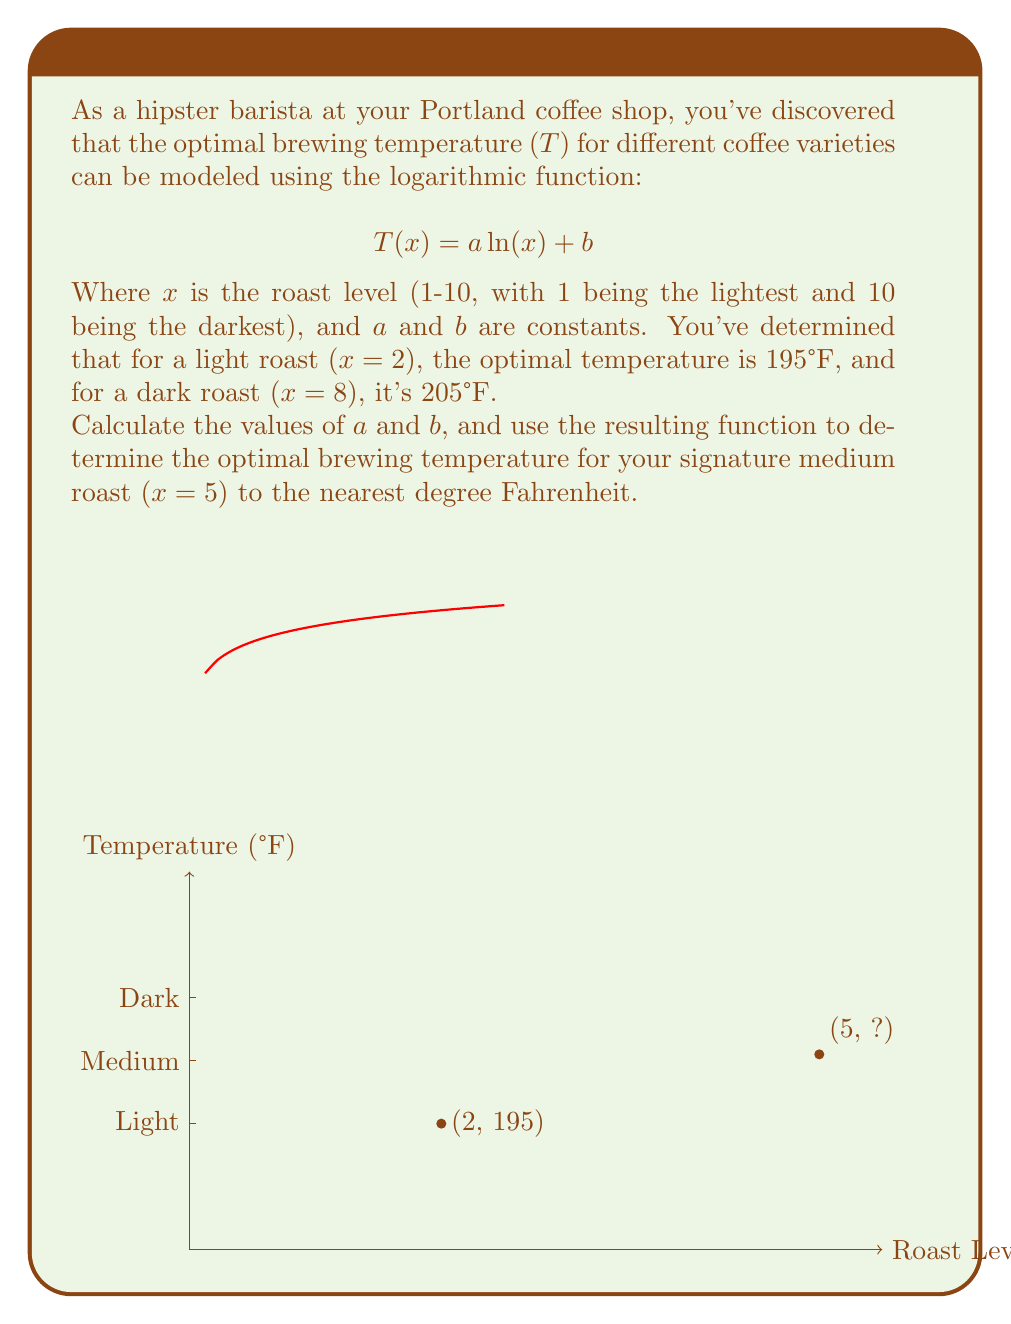Show me your answer to this math problem. Let's solve this step-by-step:

1) We have two points to work with:
   (2, 195) and (8, 205)

2) We can set up two equations using the general form $T(x) = a \ln(x) + b$:
   $$195 = a \ln(2) + b$$
   $$205 = a \ln(8) + b$$

3) Subtracting the first equation from the second:
   $$205 - 195 = a(\ln(8) - \ln(2))$$
   $$10 = a(\ln(4))$$
   $$10 = a(1.386)$$

4) Solving for $a$:
   $$a = \frac{10}{1.386} \approx 7.21$$

5) Now we can substitute this value of $a$ back into either of the original equations to solve for $b$. Let's use the first equation:
   $$195 = 7.21 \ln(2) + b$$
   $$195 = 7.21(0.693) + b$$
   $$195 = 5.00 + b$$
   $$b = 190.00$$

6) Our function is now:
   $$T(x) = 7.21 \ln(x) + 190.00$$

7) To find the optimal temperature for a medium roast (x = 5):
   $$T(5) = 7.21 \ln(5) + 190.00$$
   $$= 7.21(1.609) + 190.00$$
   $$= 11.60 + 190.00$$
   $$= 201.60$$

8) Rounding to the nearest degree:
   $$T(5) \approx 202°F$$
Answer: 202°F 